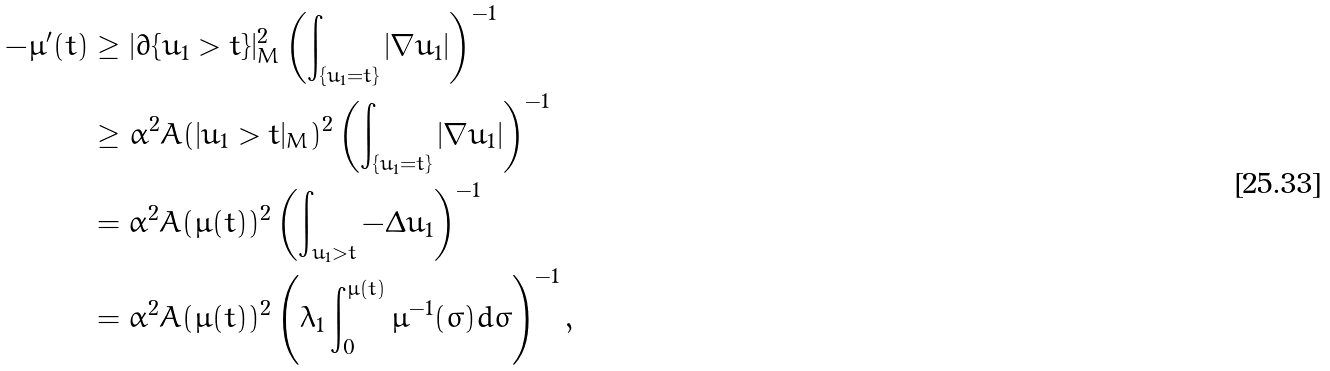<formula> <loc_0><loc_0><loc_500><loc_500>- \mu ^ { \prime } ( t ) & \geq | \partial \{ u _ { 1 } > t \} | ^ { 2 } _ { M } \left ( \int _ { \{ u _ { 1 } = t \} } | \nabla u _ { 1 } | \right ) ^ { - 1 } \\ & \geq \alpha ^ { 2 } A ( | u _ { 1 } > t | _ { M } ) ^ { 2 } \left ( \int _ { \{ u _ { 1 } = t \} } | \nabla u _ { 1 } | \right ) ^ { - 1 } \\ & = \alpha ^ { 2 } A ( \mu ( t ) ) ^ { 2 } \left ( \int _ { u _ { 1 } > t } - \Delta u _ { 1 } \right ) ^ { - 1 } \\ & = \alpha ^ { 2 } A ( \mu ( t ) ) ^ { 2 } \left ( \lambda _ { 1 } \int _ { 0 } ^ { \mu ( t ) } \mu ^ { - 1 } ( \sigma ) d \sigma \right ) ^ { - 1 } ,</formula> 